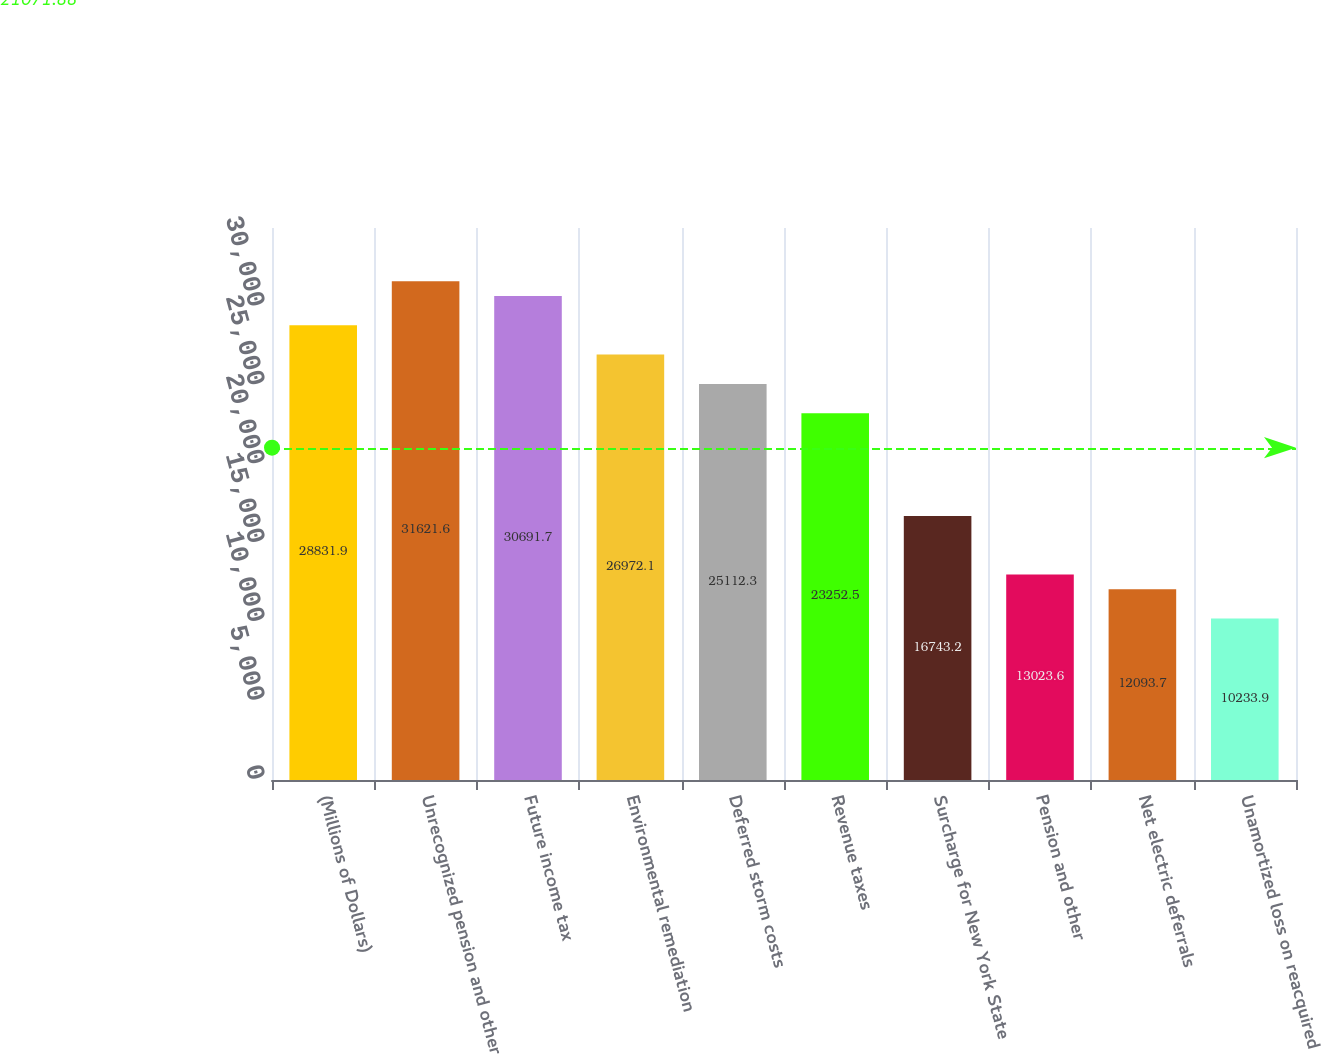<chart> <loc_0><loc_0><loc_500><loc_500><bar_chart><fcel>(Millions of Dollars)<fcel>Unrecognized pension and other<fcel>Future income tax<fcel>Environmental remediation<fcel>Deferred storm costs<fcel>Revenue taxes<fcel>Surcharge for New York State<fcel>Pension and other<fcel>Net electric deferrals<fcel>Unamortized loss on reacquired<nl><fcel>28831.9<fcel>31621.6<fcel>30691.7<fcel>26972.1<fcel>25112.3<fcel>23252.5<fcel>16743.2<fcel>13023.6<fcel>12093.7<fcel>10233.9<nl></chart> 